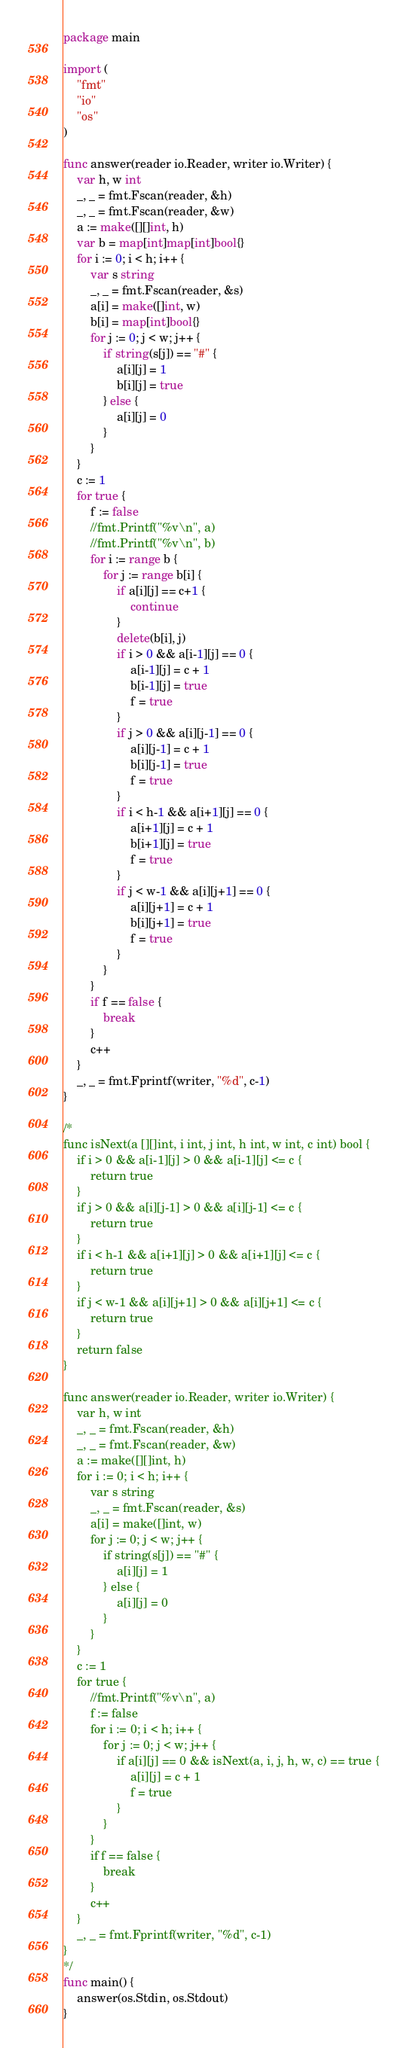Convert code to text. <code><loc_0><loc_0><loc_500><loc_500><_Go_>package main

import (
	"fmt"
	"io"
	"os"
)

func answer(reader io.Reader, writer io.Writer) {
	var h, w int
	_, _ = fmt.Fscan(reader, &h)
	_, _ = fmt.Fscan(reader, &w)
	a := make([][]int, h)
	var b = map[int]map[int]bool{}
	for i := 0; i < h; i++ {
		var s string
		_, _ = fmt.Fscan(reader, &s)
		a[i] = make([]int, w)
		b[i] = map[int]bool{}
		for j := 0; j < w; j++ {
			if string(s[j]) == "#" {
				a[i][j] = 1
				b[i][j] = true
			} else {
				a[i][j] = 0
			}
		}
	}
	c := 1
	for true {
		f := false
		//fmt.Printf("%v\n", a)
		//fmt.Printf("%v\n", b)
		for i := range b {
			for j := range b[i] {
				if a[i][j] == c+1 {
					continue
				}
				delete(b[i], j)
				if i > 0 && a[i-1][j] == 0 {
					a[i-1][j] = c + 1
					b[i-1][j] = true
					f = true
				}
				if j > 0 && a[i][j-1] == 0 {
					a[i][j-1] = c + 1
					b[i][j-1] = true
					f = true
				}
				if i < h-1 && a[i+1][j] == 0 {
					a[i+1][j] = c + 1
					b[i+1][j] = true
					f = true
				}
				if j < w-1 && a[i][j+1] == 0 {
					a[i][j+1] = c + 1
					b[i][j+1] = true
					f = true
				}
			}
		}
		if f == false {
			break
		}
		c++
	}
	_, _ = fmt.Fprintf(writer, "%d", c-1)
}

/*
func isNext(a [][]int, i int, j int, h int, w int, c int) bool {
	if i > 0 && a[i-1][j] > 0 && a[i-1][j] <= c {
		return true
	}
	if j > 0 && a[i][j-1] > 0 && a[i][j-1] <= c {
		return true
	}
	if i < h-1 && a[i+1][j] > 0 && a[i+1][j] <= c {
		return true
	}
	if j < w-1 && a[i][j+1] > 0 && a[i][j+1] <= c {
		return true
	}
	return false
}

func answer(reader io.Reader, writer io.Writer) {
	var h, w int
	_, _ = fmt.Fscan(reader, &h)
	_, _ = fmt.Fscan(reader, &w)
	a := make([][]int, h)
	for i := 0; i < h; i++ {
		var s string
		_, _ = fmt.Fscan(reader, &s)
		a[i] = make([]int, w)
		for j := 0; j < w; j++ {
			if string(s[j]) == "#" {
				a[i][j] = 1
			} else {
				a[i][j] = 0
			}
		}
	}
	c := 1
	for true {
		//fmt.Printf("%v\n", a)
		f := false
		for i := 0; i < h; i++ {
			for j := 0; j < w; j++ {
				if a[i][j] == 0 && isNext(a, i, j, h, w, c) == true {
					a[i][j] = c + 1
					f = true
				}
			}
		}
		if f == false {
			break
		}
		c++
	}
	_, _ = fmt.Fprintf(writer, "%d", c-1)
}
*/
func main() {
	answer(os.Stdin, os.Stdout)
}
</code> 